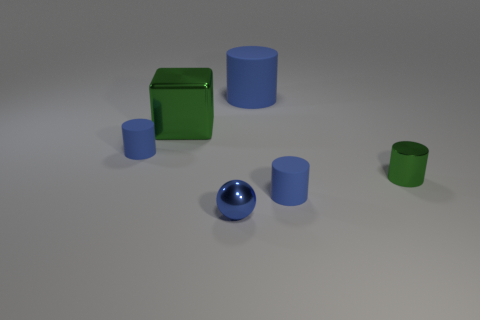How many blue cylinders must be subtracted to get 1 blue cylinders? 2 Subtract all blue rubber cylinders. How many cylinders are left? 1 Add 3 small blue cylinders. How many objects exist? 9 Subtract all green cylinders. How many cylinders are left? 3 Add 1 large green things. How many large green things exist? 2 Subtract 0 brown cylinders. How many objects are left? 6 Subtract all cylinders. How many objects are left? 2 Subtract 1 cylinders. How many cylinders are left? 3 Subtract all red cylinders. Subtract all blue cubes. How many cylinders are left? 4 Subtract all gray cubes. How many blue cylinders are left? 3 